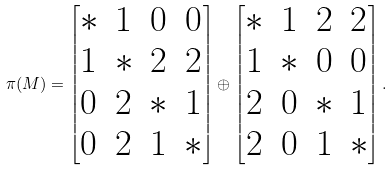Convert formula to latex. <formula><loc_0><loc_0><loc_500><loc_500>\pi ( M ) = \begin{bmatrix} * & 1 & 0 & 0 \\ 1 & * & 2 & 2 \\ 0 & 2 & * & 1 \\ 0 & 2 & 1 & * \end{bmatrix} \oplus \begin{bmatrix} * & 1 & 2 & 2 \\ 1 & * & 0 & 0 \\ 2 & 0 & * & 1 \\ 2 & 0 & 1 & * \end{bmatrix} .</formula> 